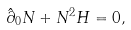Convert formula to latex. <formula><loc_0><loc_0><loc_500><loc_500>\hat { \partial } _ { 0 } N + N ^ { 2 } H = 0 ,</formula> 